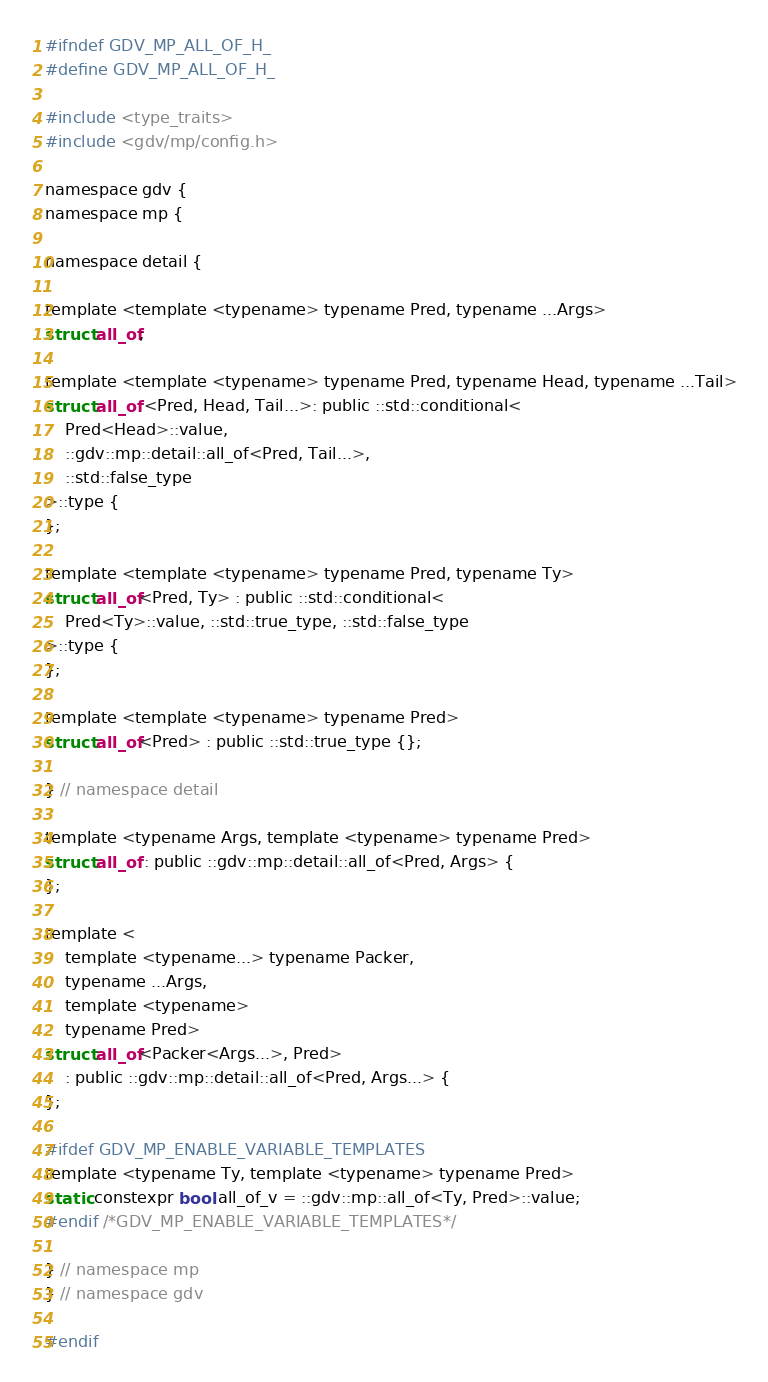Convert code to text. <code><loc_0><loc_0><loc_500><loc_500><_C_>#ifndef GDV_MP_ALL_OF_H_
#define GDV_MP_ALL_OF_H_

#include <type_traits>
#include <gdv/mp/config.h>

namespace gdv {
namespace mp {

namespace detail {

template <template <typename> typename Pred, typename ...Args>
struct all_of;

template <template <typename> typename Pred, typename Head, typename ...Tail>
struct all_of <Pred, Head, Tail...>: public ::std::conditional<
    Pred<Head>::value,
    ::gdv::mp::detail::all_of<Pred, Tail...>,
    ::std::false_type
>::type {
};

template <template <typename> typename Pred, typename Ty>
struct all_of<Pred, Ty> : public ::std::conditional<
    Pred<Ty>::value, ::std::true_type, ::std::false_type
>::type {
};

template <template <typename> typename Pred>
struct all_of<Pred> : public ::std::true_type {};

} // namespace detail

template <typename Args, template <typename> typename Pred>
struct all_of : public ::gdv::mp::detail::all_of<Pred, Args> {
};

template <
    template <typename...> typename Packer,
    typename ...Args,
    template <typename>
    typename Pred>
struct all_of<Packer<Args...>, Pred>
    : public ::gdv::mp::detail::all_of<Pred, Args...> {
};

#ifdef GDV_MP_ENABLE_VARIABLE_TEMPLATES
template <typename Ty, template <typename> typename Pred>
static constexpr bool all_of_v = ::gdv::mp::all_of<Ty, Pred>::value;
#endif /*GDV_MP_ENABLE_VARIABLE_TEMPLATES*/

} // namespace mp
} // namespace gdv

#endif
</code> 